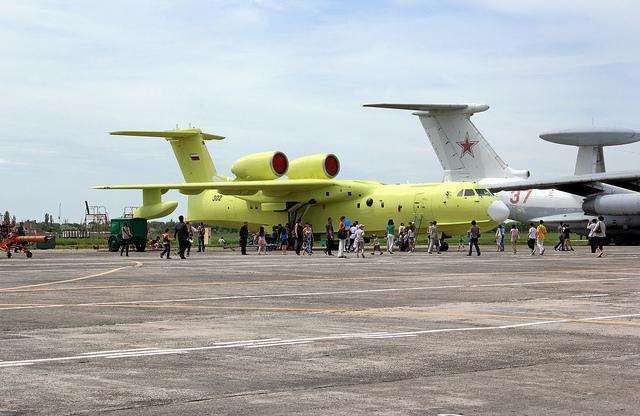What item is painted in an unconventional color?
Select the accurate response from the four choices given to answer the question.
Options: Balloon, nearest plane, tarmac, farthest plane. Nearest plane. 